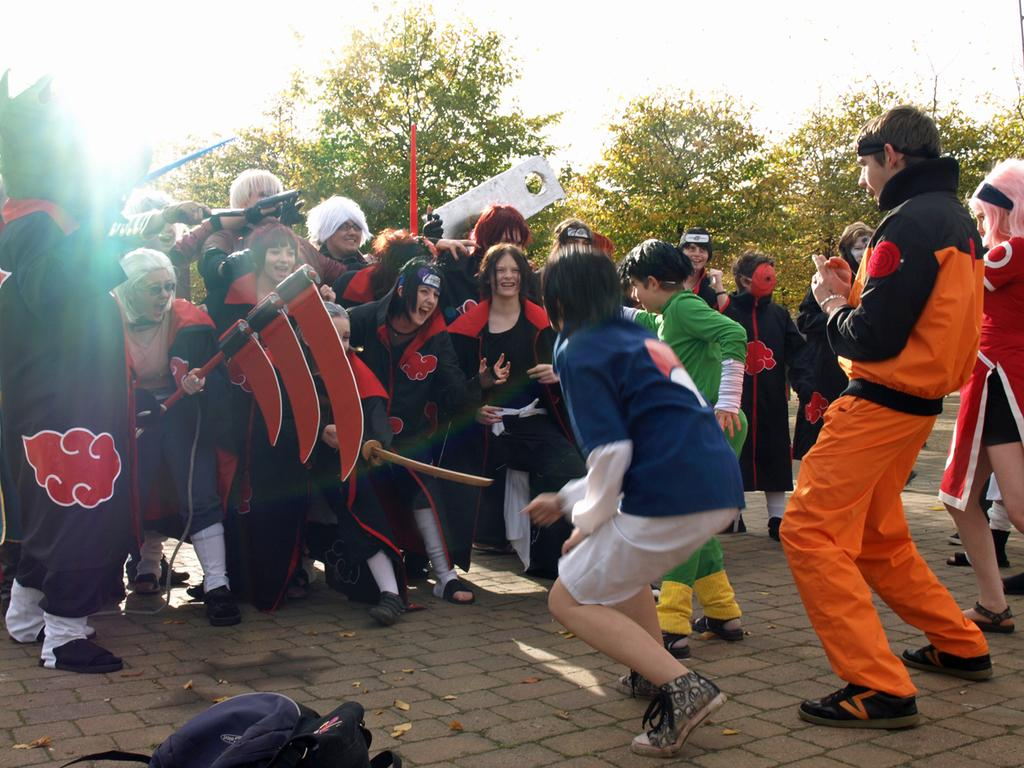What are the people in the image wearing? The people in the image are wearing costumes. What can be seen in the background of the image? There are trees and the sky visible in the background of the image. What is the surface at the bottom of the image? There is pavement at the bottom of the image. What type of voice can be heard coming from the bean in the image? There is no bean present in the image, and therefore no voice can be heard coming from it. 